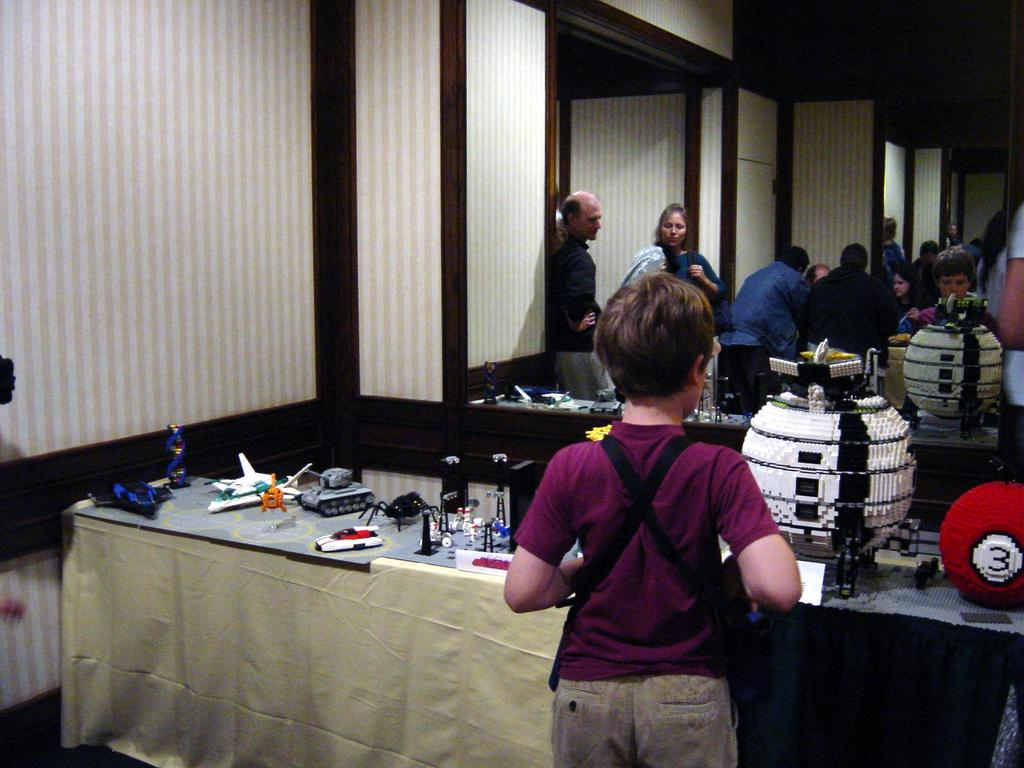Who is present in the image? There is a person in the image. What is the person doing in the image? The person is looking at toys. Can you describe the background of the image? There is a group of persons in the background of the image. What color is the sheet on the left side of the image? There is no mention of a sheet in the facts, only an image. However, based on the facts provided, we can say that there is a white color sheet on the left side of the image. What type of ornament can be seen hanging from the club in the image? There is no mention of a club or ornament in the facts provided. The image only contains a person looking at toys, a group of persons in the background, and a white color sheet on the left side. 